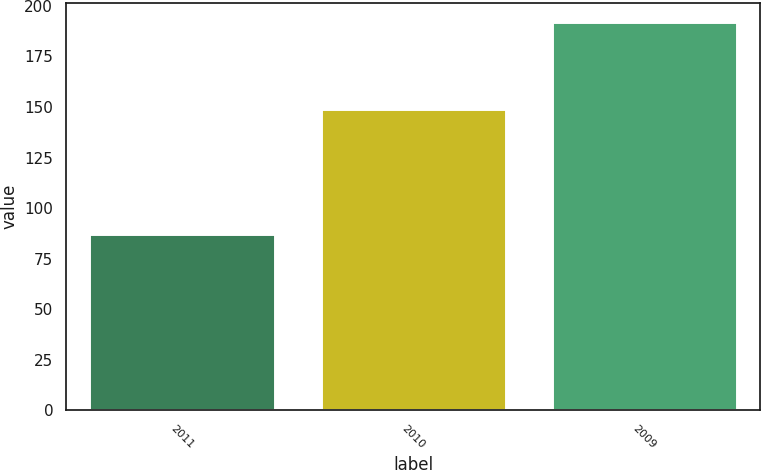Convert chart. <chart><loc_0><loc_0><loc_500><loc_500><bar_chart><fcel>2011<fcel>2010<fcel>2009<nl><fcel>87<fcel>149<fcel>192<nl></chart> 